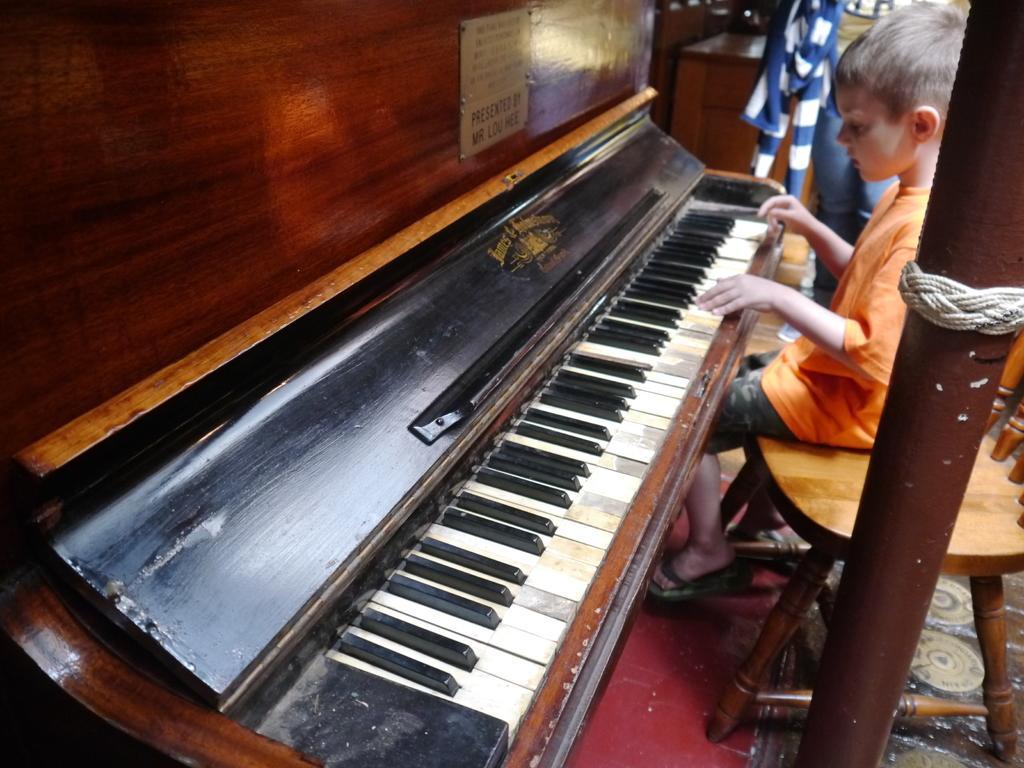Could you give a brief overview of what you see in this image? A kid is playing piano. 